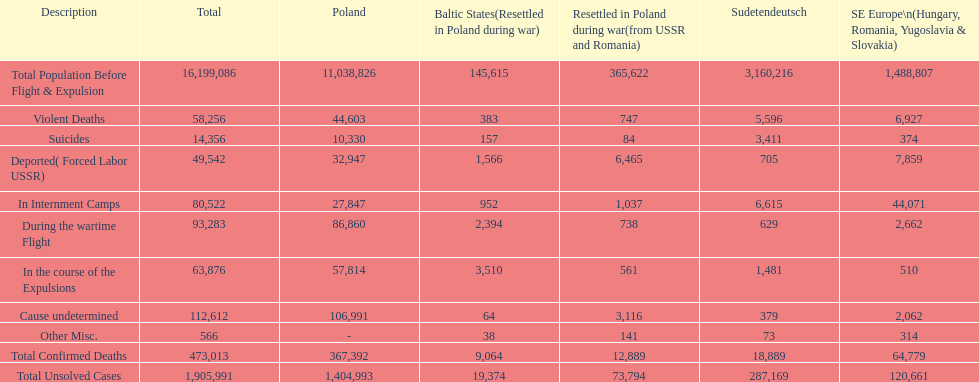What are all of the descriptions? Total Population Before Flight & Expulsion, Violent Deaths, Suicides, Deported( Forced Labor USSR), In Internment Camps, During the wartime Flight, In the course of the Expulsions, Cause undetermined, Other Misc., Total Confirmed Deaths, Total Unsolved Cases. What were their total number of deaths? 16,199,086, 58,256, 14,356, 49,542, 80,522, 93,283, 63,876, 112,612, 566, 473,013, 1,905,991. What about just from violent deaths? 58,256. 